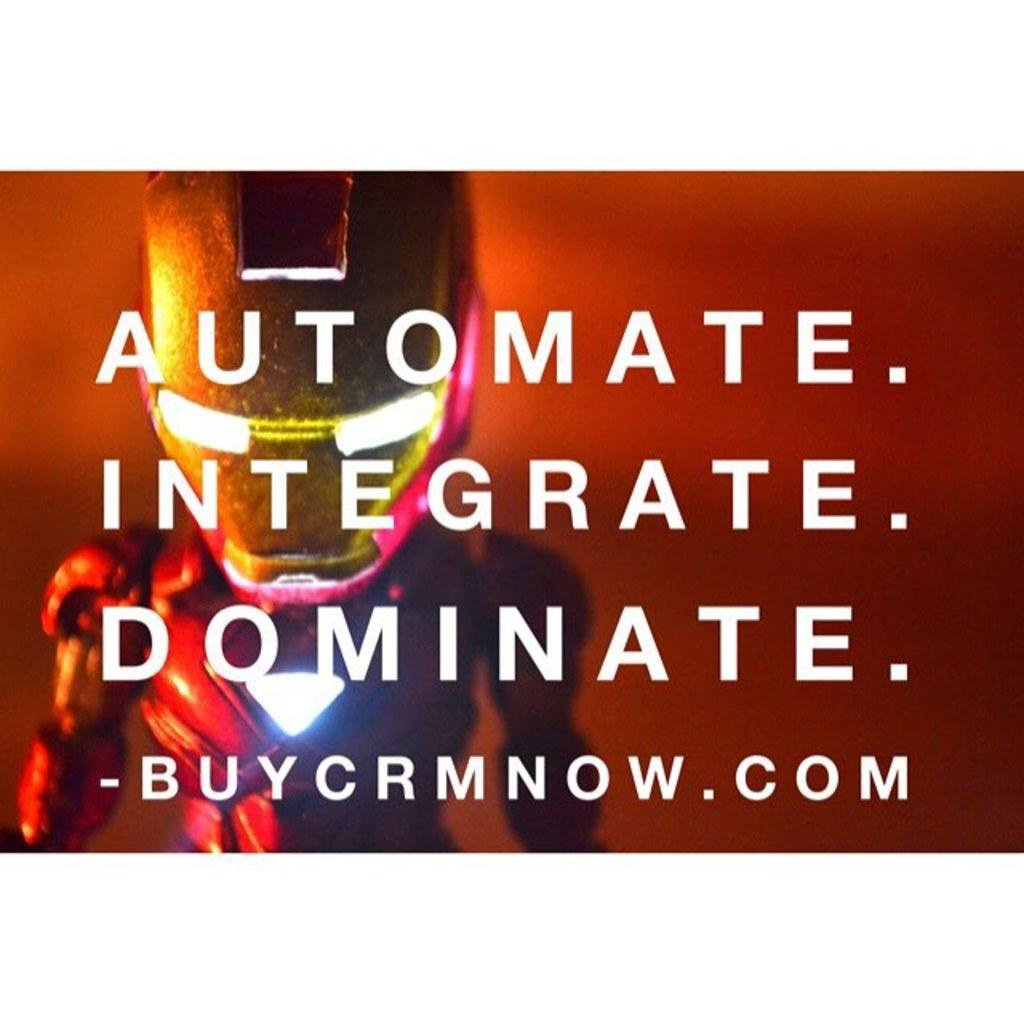<image>
Offer a succinct explanation of the picture presented. a character that has the word automate in front of him 